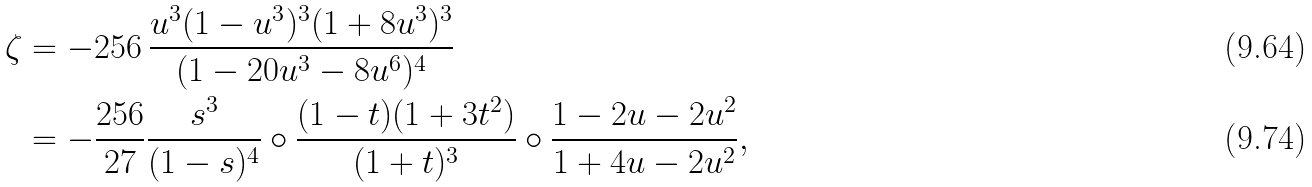Convert formula to latex. <formula><loc_0><loc_0><loc_500><loc_500>\zeta & = - 2 5 6 \, \frac { u ^ { 3 } ( 1 - u ^ { 3 } ) ^ { 3 } ( 1 + 8 u ^ { 3 } ) ^ { 3 } } { ( 1 - 2 0 u ^ { 3 } - 8 u ^ { 6 } ) ^ { 4 } } \\ & = - \frac { 2 5 6 } { 2 7 } \frac { s ^ { 3 } } { ( 1 - s ) ^ { 4 } } \circ \frac { ( 1 - t ) ( 1 + 3 t ^ { 2 } ) } { ( 1 + t ) ^ { 3 } } \circ \frac { 1 - 2 u - 2 u ^ { 2 } } { 1 + 4 u - 2 u ^ { 2 } } ,</formula> 